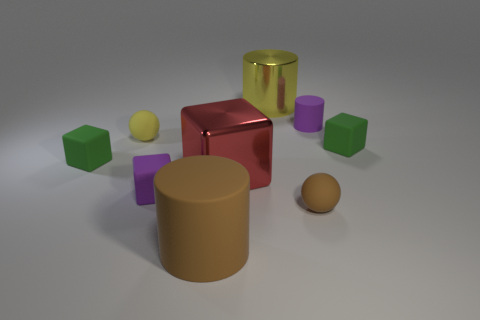What is the size of the object that is both left of the yellow metallic object and to the right of the big rubber object?
Provide a succinct answer. Large. How many other things are the same color as the tiny cylinder?
Keep it short and to the point. 1. Is the tiny brown ball made of the same material as the large object on the left side of the red shiny cube?
Give a very brief answer. Yes. What is the shape of the object that is both on the left side of the tiny rubber cylinder and behind the yellow sphere?
Keep it short and to the point. Cylinder. The red block that is the same material as the yellow cylinder is what size?
Make the answer very short. Large. How many things are matte cylinders behind the large red cube or rubber objects that are to the left of the red cube?
Offer a terse response. 5. There is a rubber cube that is in front of the red metallic cube; is it the same size as the purple cylinder?
Keep it short and to the point. Yes. The rubber ball that is on the left side of the small brown thing is what color?
Your response must be concise. Yellow. What is the color of the other tiny thing that is the same shape as the yellow metal object?
Your answer should be very brief. Purple. There is a tiny green cube that is left of the purple thing that is right of the red metal object; how many small purple rubber cylinders are to the left of it?
Provide a succinct answer. 0. 